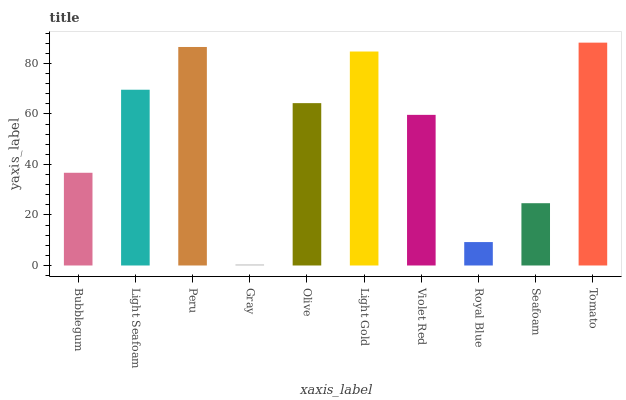Is Light Seafoam the minimum?
Answer yes or no. No. Is Light Seafoam the maximum?
Answer yes or no. No. Is Light Seafoam greater than Bubblegum?
Answer yes or no. Yes. Is Bubblegum less than Light Seafoam?
Answer yes or no. Yes. Is Bubblegum greater than Light Seafoam?
Answer yes or no. No. Is Light Seafoam less than Bubblegum?
Answer yes or no. No. Is Olive the high median?
Answer yes or no. Yes. Is Violet Red the low median?
Answer yes or no. Yes. Is Bubblegum the high median?
Answer yes or no. No. Is Peru the low median?
Answer yes or no. No. 